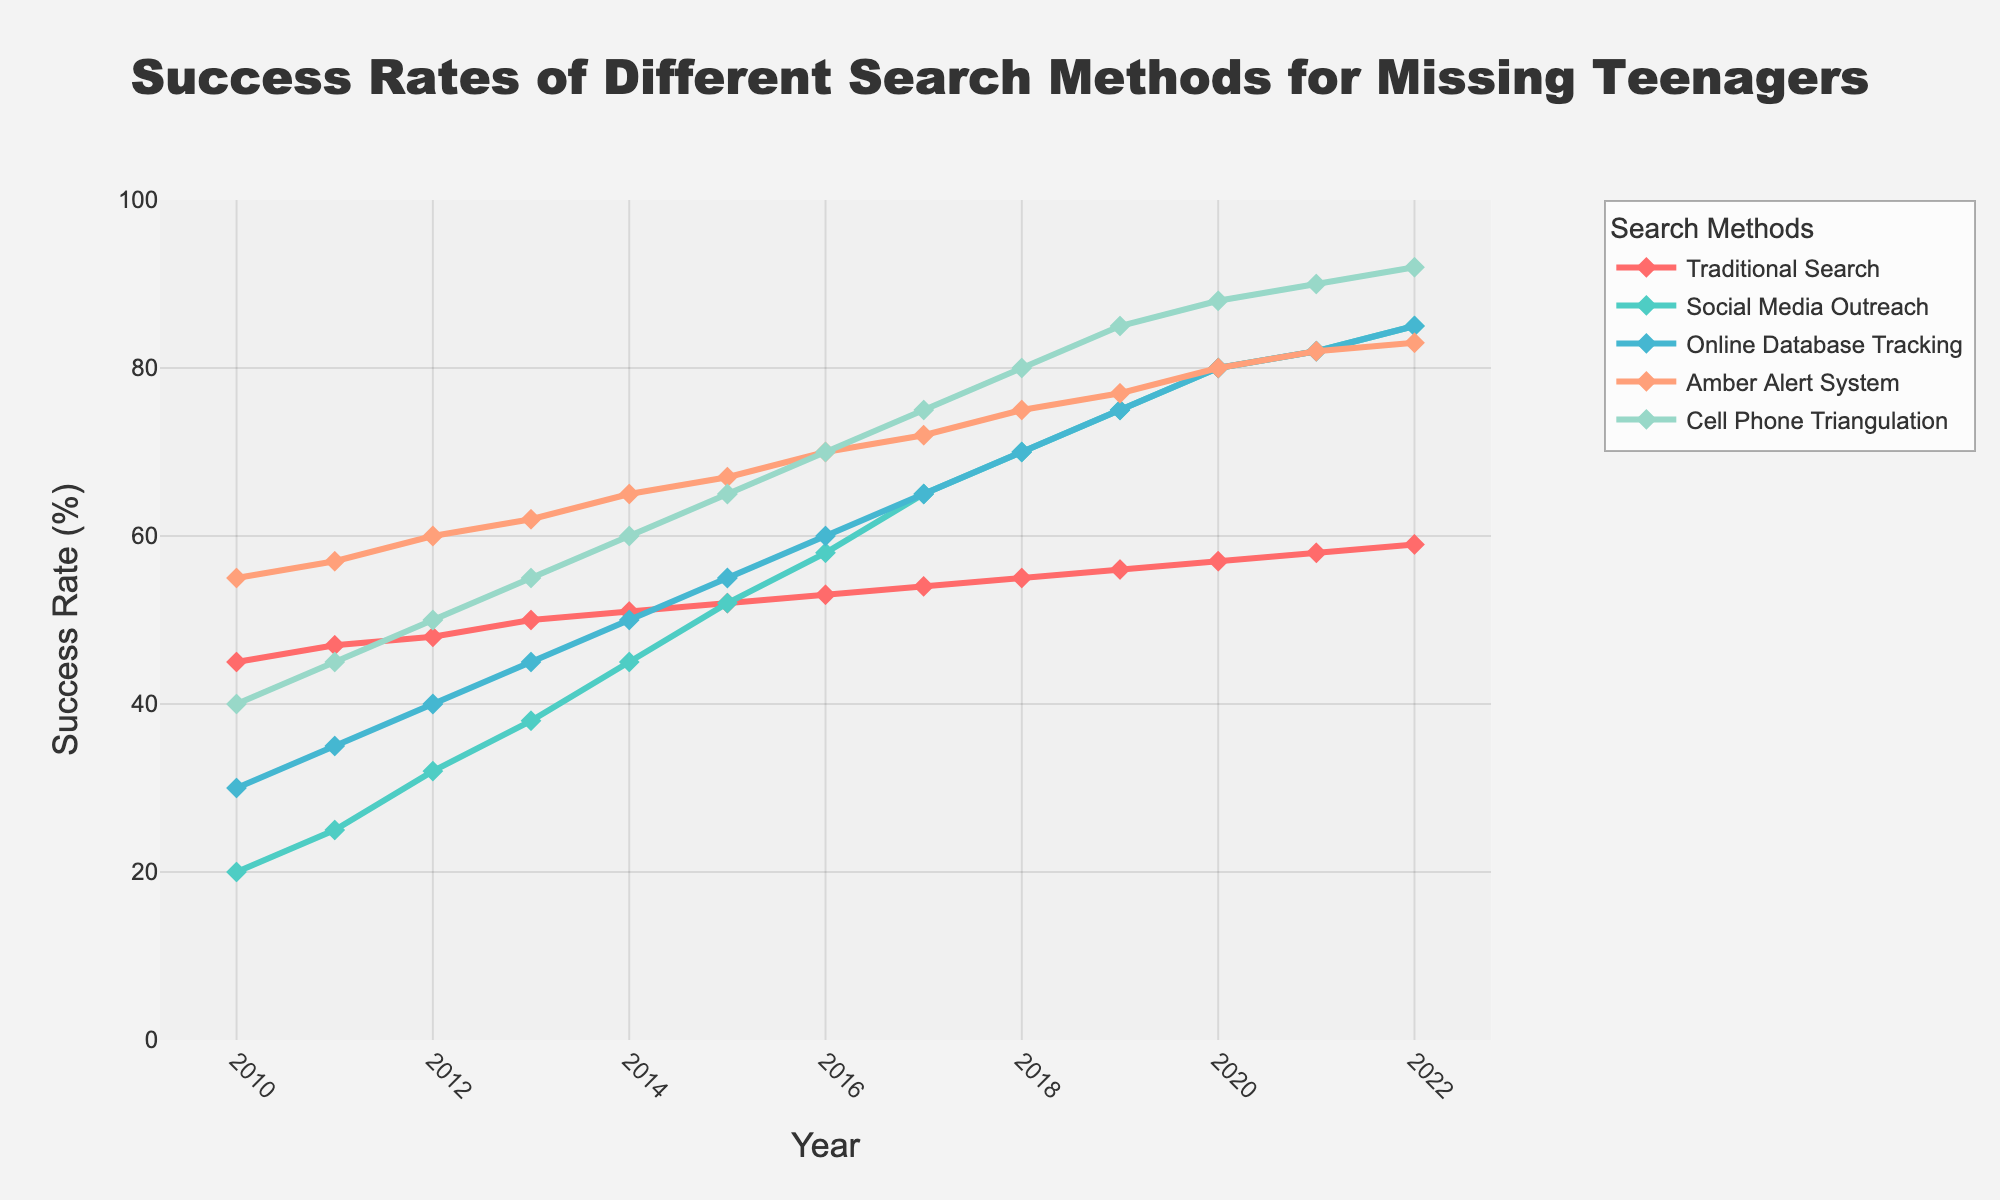What's the overall trend in the success rates of the Amber Alert System from 2010 to 2022? From 2010 to 2022, the Amber Alert System's success rate shows a general upward trend each year. Starting at 55% in 2010 and increasing to 83% in 2022 indicates consistent improvement over time.
Answer: An increasing trend Which search method had the highest success rate in 2022? The figure shows that Cell Phone Triangulation had the highest success rate in 2022, reaching 92%.
Answer: Cell Phone Triangulation How does the success rate of Social Media Outreach in 2010 compare with 2012? In 2010, the success rate of Social Media Outreach was 20%. By 2012, it had increased to 32%, showing a significant improvement.
Answer: The 2012 rate is 12% higher Which search method had the smallest improvement in success rate from 2010 to 2022? Traditional Search had the smallest improvement. In 2010, its success rate was 45%, and by 2022 it had risen to 59%, an increase of 14%, which is less than the improvements seen in the other methods.
Answer: Traditional Search What is the average success rate of Online Database Tracking from 2010 to 2022? To calculate the average, sum the success rates for each year from 2010 to 2022, and then divide by the number of years. The sum is 30+35+40+45+50+55+60+65+70+75+80+82+85 = 737. Divide 737 by 13 (number of years) to get approximately 56.69%.
Answer: 56.69% How do the success rates of Cell Phone Triangulation and Traditional Search compare in 2015? In 2015, the success rate for Cell Phone Triangulation was 65%, while for Traditional Search it was 52%. Cell Phone Triangulation had a higher success rate by 13%.
Answer: 13% higher for Cell Phone Triangulation What is the difference in success rates between the highest and lowest performing methods in 2016? In 2016, Cell Phone Triangulation had the highest success rate at 70%, and Social Media Outreach had the lowest at 58%. The difference between them is 12%.
Answer: 12% Between which years did Social Media Outreach see the greatest increase in success rate? Social Media Outreach saw the greatest increase between 2011 and 2012, with an increase from 25% to 32%, a 7% rise.
Answer: 2011 to 2012 What visual change can be observed in the lines representing Online Database Tracking and Social Media Outreach between 2016 and 2020? Both lines show a consistent increase in the success rates, moving upward more sharply compared to previous years. Online Database Tracking increased from 60% to 80%, and Social Media Outreach from 58% to 80%.
Answer: Both lines rise sharply In which year did all five search methods show an upward trend compared to the previous year? In 2011, all five search methods improved compared to 2010, showing increased success rates: Traditional Search (45% to 47%), Social Media Outreach (20% to 25%), Online Database Tracking (30% to 35%), Amber Alert System (55% to 57%), and Cell Phone Triangulation (40% to 45%).
Answer: 2011 